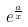<formula> <loc_0><loc_0><loc_500><loc_500>e ^ { \frac { a } { x } }</formula> 